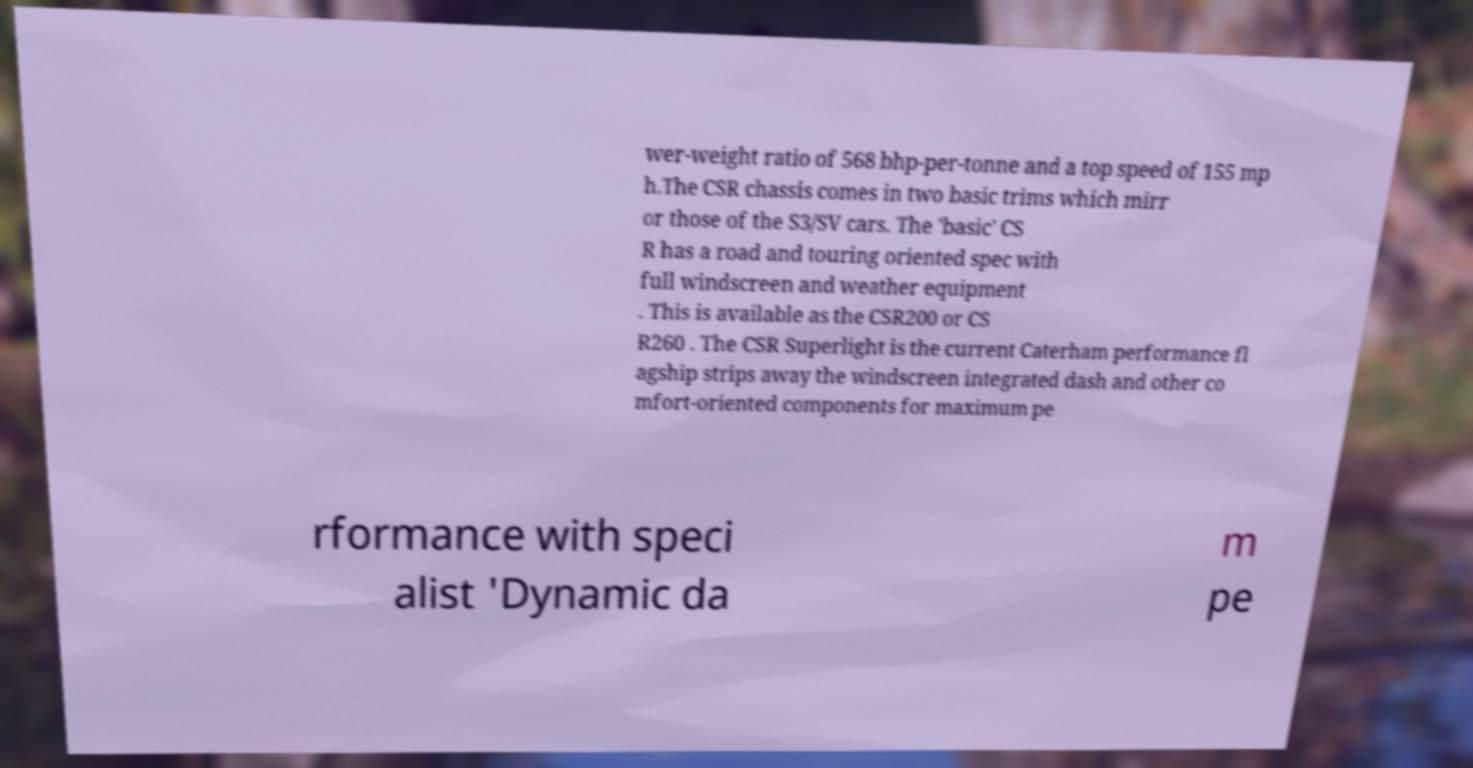Could you assist in decoding the text presented in this image and type it out clearly? wer-weight ratio of 568 bhp-per-tonne and a top speed of 155 mp h.The CSR chassis comes in two basic trims which mirr or those of the S3/SV cars. The 'basic' CS R has a road and touring oriented spec with full windscreen and weather equipment . This is available as the CSR200 or CS R260 . The CSR Superlight is the current Caterham performance fl agship strips away the windscreen integrated dash and other co mfort-oriented components for maximum pe rformance with speci alist 'Dynamic da m pe 